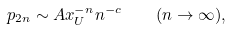<formula> <loc_0><loc_0><loc_500><loc_500>p _ { 2 n } \sim A x _ { U } ^ { - n } n ^ { - c } \quad ( n \to \infty ) ,</formula> 